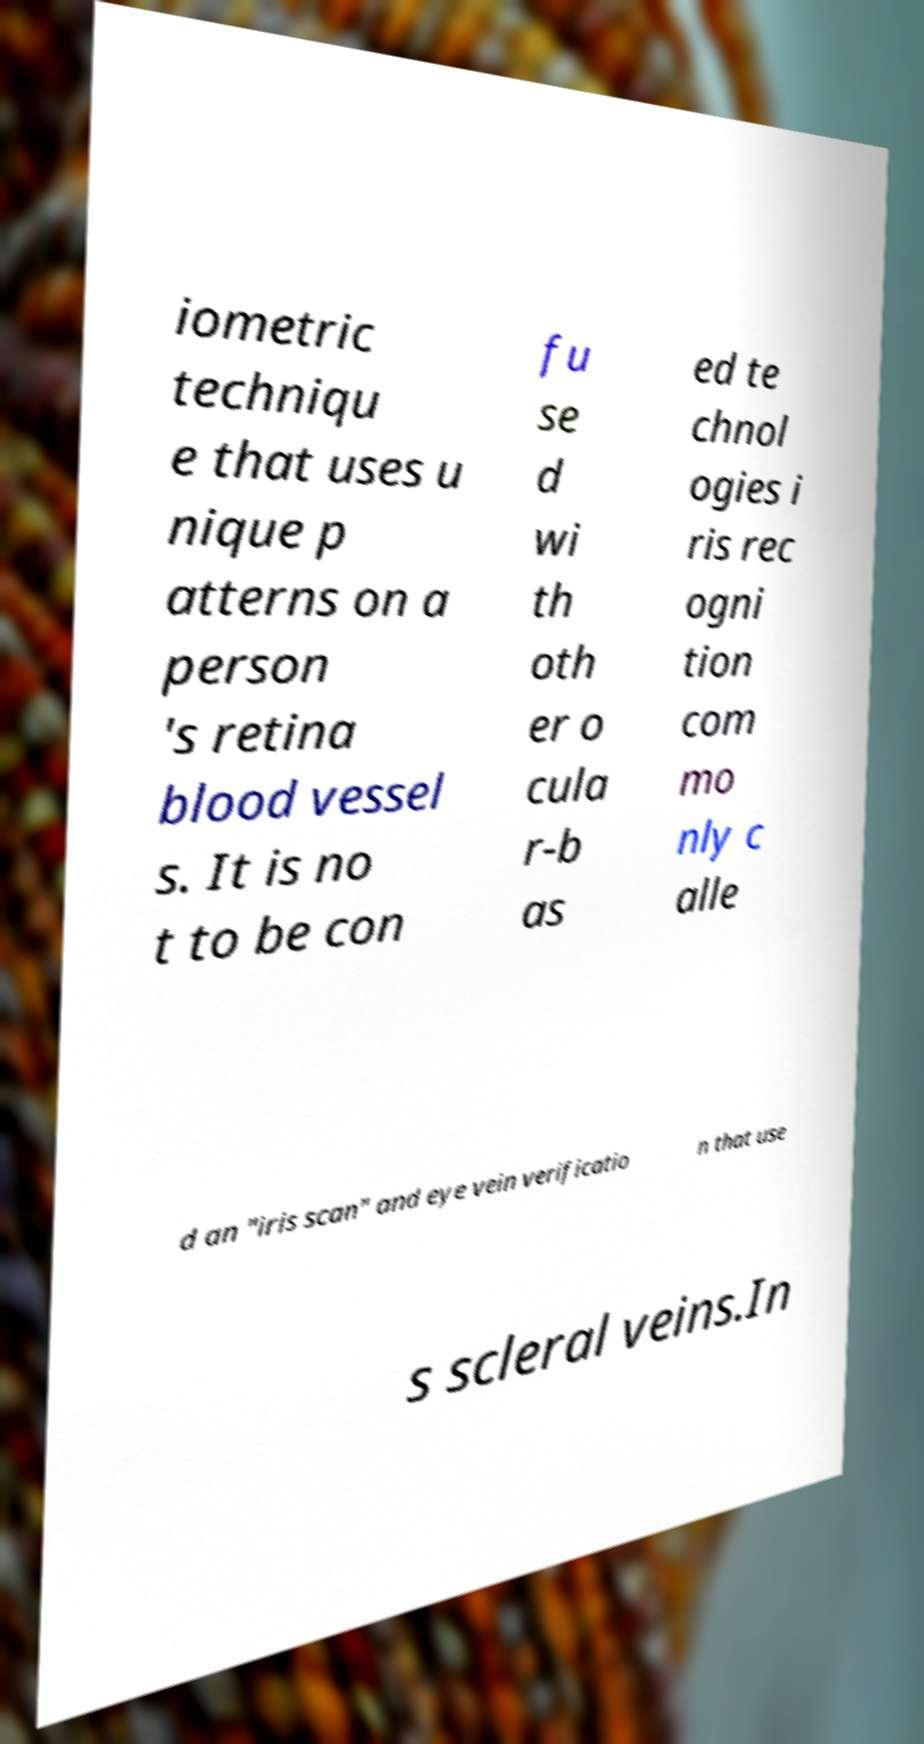Please identify and transcribe the text found in this image. iometric techniqu e that uses u nique p atterns on a person 's retina blood vessel s. It is no t to be con fu se d wi th oth er o cula r-b as ed te chnol ogies i ris rec ogni tion com mo nly c alle d an "iris scan" and eye vein verificatio n that use s scleral veins.In 